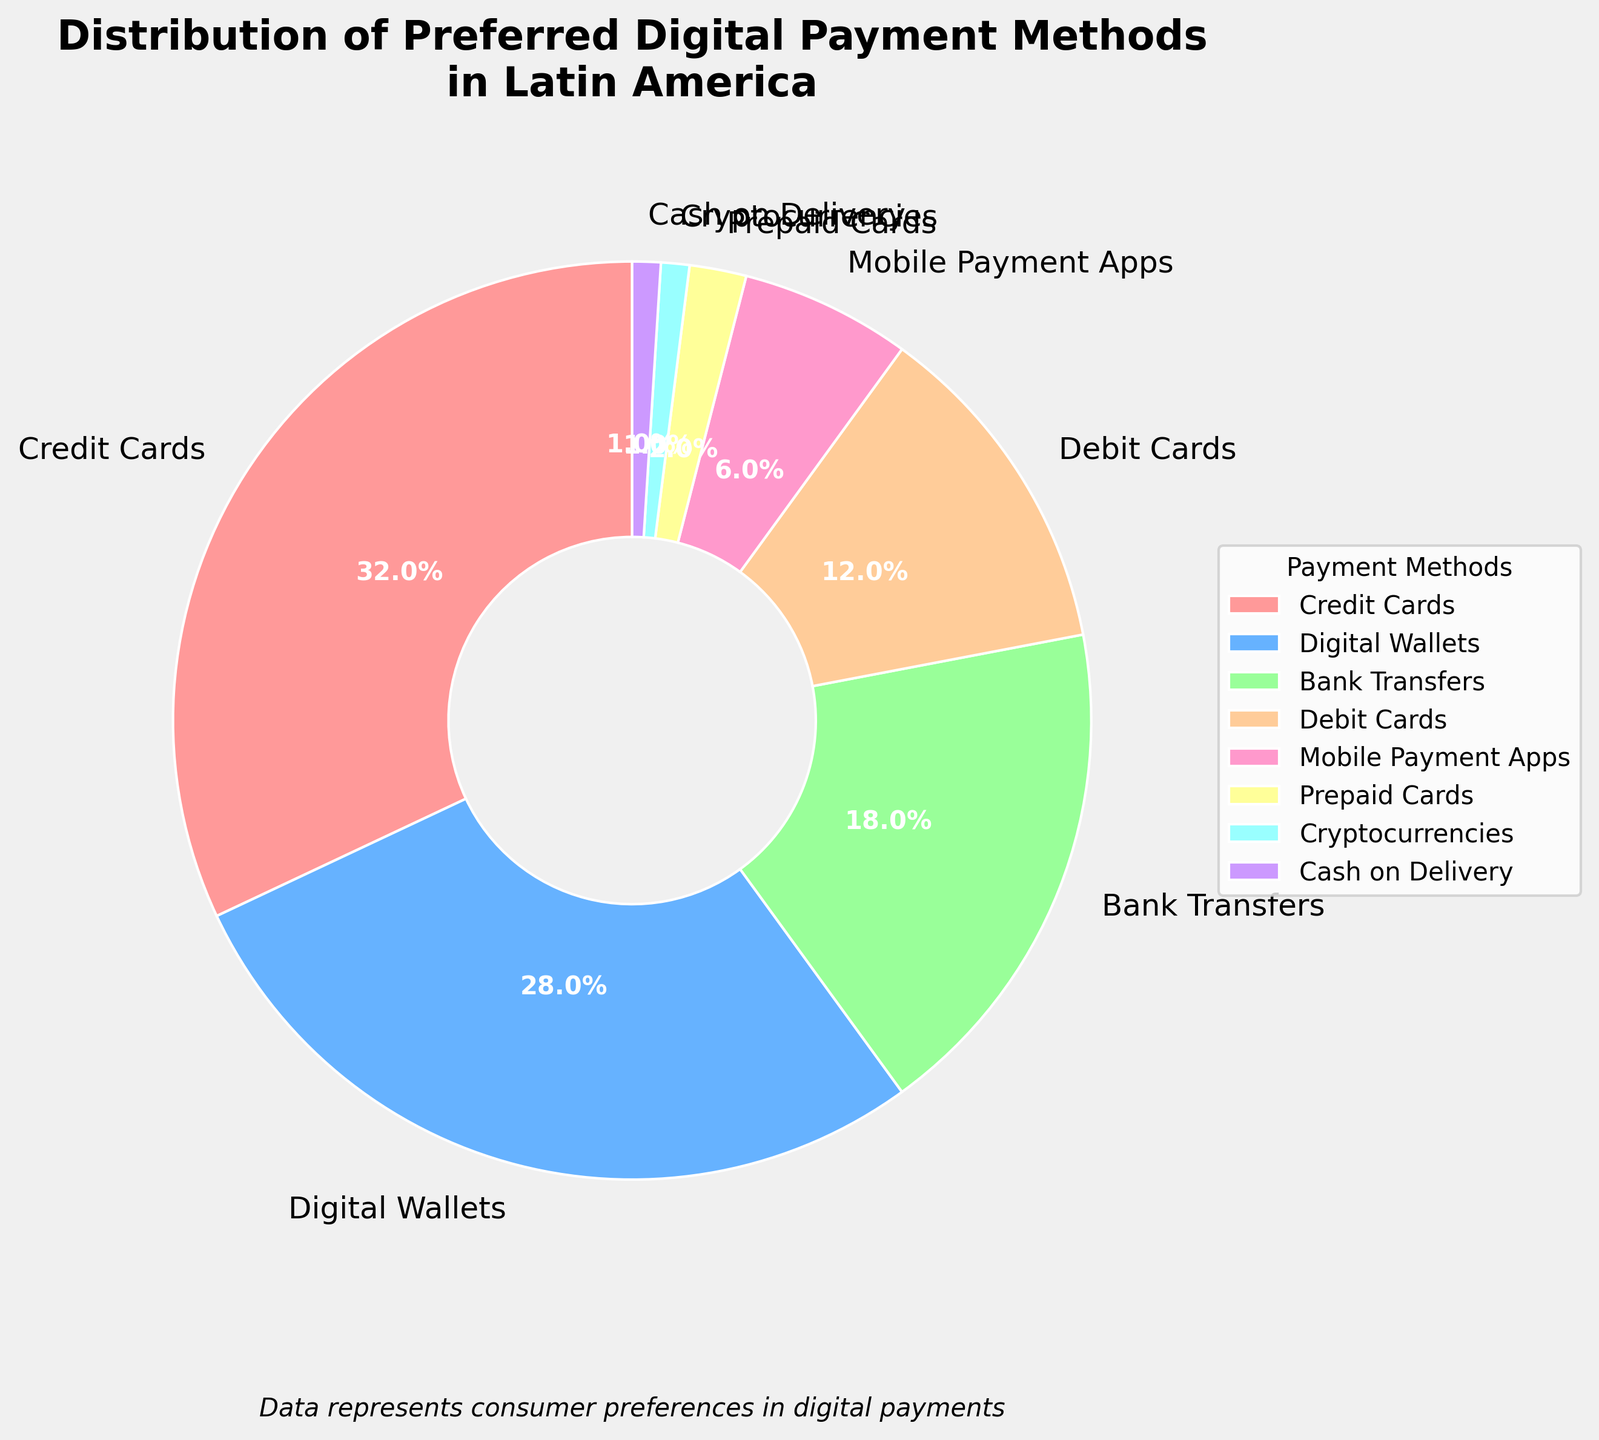Which payment method is the most preferred among Latin American consumers? The payment method with the highest percentage value in the pie chart is the most preferred. The figure shows that "Credit Cards" has the largest slice representing 32%.
Answer: Credit Cards What is the combined percentage of bank transfers and debit cards as preferred payment methods? To find the combined percentage, add the percentage values of "Bank Transfers" (18%) and "Debit Cards" (12%). The sum is 18% + 12% = 30%.
Answer: 30% Which category has a smaller preference: mobile payment apps or cryptocurrencies? Compare the slices representing "Mobile Payment Apps" and "Cryptocurrencies". "Mobile Payment Apps" is 6% while "Cryptocurrencies" is 1%. Therefore, cryptocurrencies have a smaller preference.
Answer: Cryptocurrencies How much larger is the preference for digital wallets compared to prepaid cards? Subtract the percentage of "Prepaid Cards" (2%) from "Digital Wallets" (28%). The difference is 28% - 2% = 26%.
Answer: 26% What is the least preferred payment method among the given options? The least preferred payment method corresponds to the slice with the smallest percentage. Both "Cryptocurrencies" and "Cash on Delivery" are at 1%, but since both share the smallest percentage, either could be the correct answer.
Answer: Cryptocurrencies or Cash on Delivery What percentage of consumers prefer either credit cards or digital wallets? Add the percentage values of "Credit Cards" (32%) and "Digital Wallets" (28%). The sum is 32% + 28% = 60%.
Answer: 60% Which payment methods together account for nearly half of the consumer preferences? Look for the combination of payment methods whose percentages add up to around 50%. "Credit Cards" (32%) and "Digital Wallets" (28%) together account for 32% + 28% = 60%, while "Digital Wallets" (28%), "Bank Transfers" (18%), and "Debit Cards" (12%) combined account for 28% + 18% + 12% = 58%. The pair closest to 50% is "Credit Cards" alone at 32%.
Answer: Credit Cards alone doesn't sum to near half, no exact combination sums nearly to half directly without exceeding What is the visual difference in the pie chart slices between debit cards and mobile payment apps? Compare the slices represented by "Debit Cards" and "Mobile Payment Apps". "Debit Cards" has a visibly larger slice at 12%, whereas "Mobile Payment Apps" is at 6%. Therefore, the slice for debit cards is larger or has a greater proportion.
Answer: Debit Cards have a larger slice Is there any payment method that has a slice smaller than 10%? Check the figure for any slices representing less than 10%. "Debit Cards" (12%), "Mobile Payment Apps" (6%), "Prepaid Cards" (2%), "Cryptocurrencies" (1%), and "Cash on Delivery" (1%) all have slices smaller than 10%.
Answer: Yes, several methods including Mobile Payment Apps, Prepaid Cards, Cryptocurrencies, and Cash on Delivery Which color represents the preferred method for bank transfers in the chart? Identify the color corresponding to the "Bank Transfers" label in the pie chart. This method is generally indicated visually to aid differentiation. The specific color assigned visually (generally something like blue) represents "Bank Transfers."
Answer: Depending on the color scheme, Bank Transfers likely have blue (check figure for specific) 